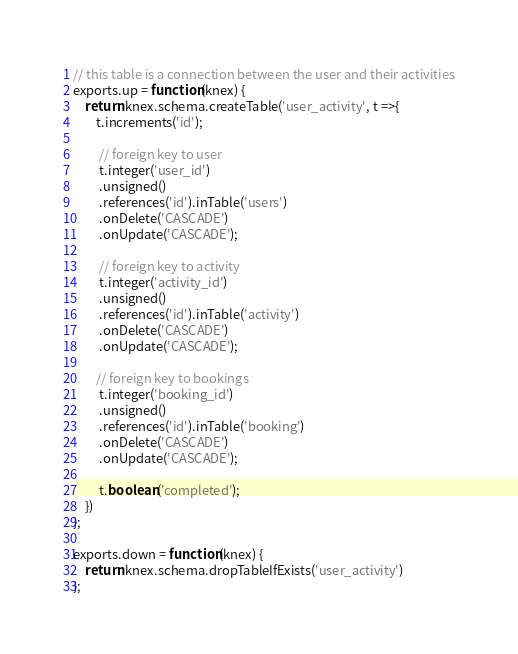<code> <loc_0><loc_0><loc_500><loc_500><_JavaScript_>// this table is a connection between the user and their activities
exports.up = function(knex) {
    return knex.schema.createTable('user_activity', t =>{
        t.increments('id');

         // foreign key to user
         t.integer('user_id')
         .unsigned()
         .references('id').inTable('users')
         .onDelete('CASCADE')
         .onUpdate('CASCADE');

         // foreign key to activity
         t.integer('activity_id')
         .unsigned()
         .references('id').inTable('activity')
         .onDelete('CASCADE')
         .onUpdate('CASCADE');

        // foreign key to bookings
         t.integer('booking_id')
         .unsigned()
         .references('id').inTable('booking')
         .onDelete('CASCADE')
         .onUpdate('CASCADE');

         t.boolean('completed');
    })
};

exports.down = function(knex) {
    return knex.schema.dropTableIfExists('user_activity')
};
</code> 